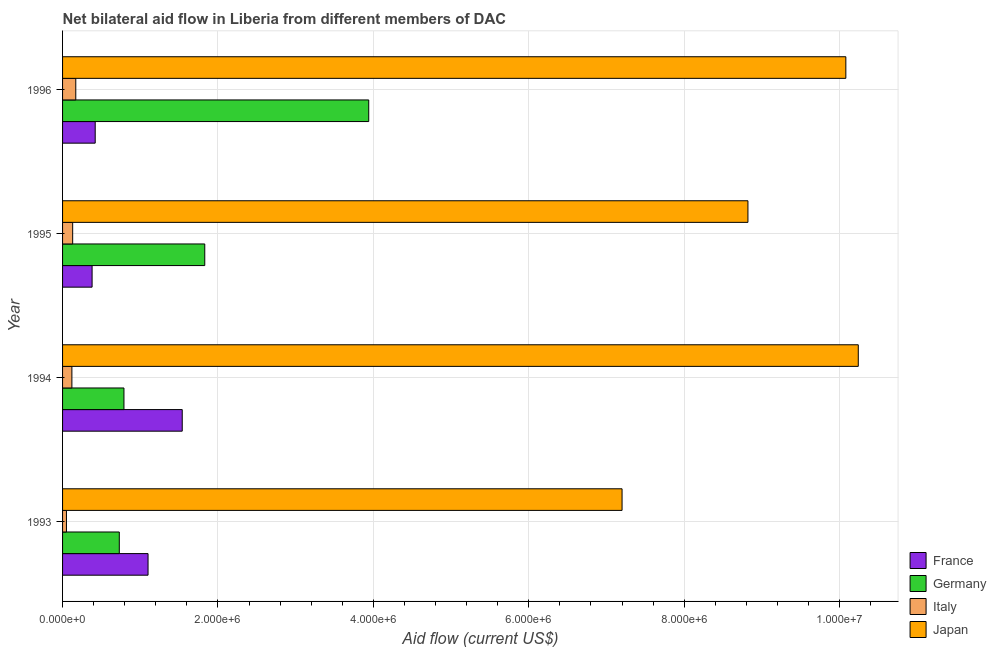How many different coloured bars are there?
Provide a succinct answer. 4. How many groups of bars are there?
Your answer should be very brief. 4. Are the number of bars per tick equal to the number of legend labels?
Offer a very short reply. Yes. Are the number of bars on each tick of the Y-axis equal?
Offer a terse response. Yes. How many bars are there on the 3rd tick from the top?
Your answer should be compact. 4. How many bars are there on the 1st tick from the bottom?
Ensure brevity in your answer.  4. In how many cases, is the number of bars for a given year not equal to the number of legend labels?
Offer a terse response. 0. What is the amount of aid given by france in 1993?
Make the answer very short. 1.10e+06. Across all years, what is the maximum amount of aid given by france?
Offer a terse response. 1.54e+06. Across all years, what is the minimum amount of aid given by germany?
Make the answer very short. 7.30e+05. In which year was the amount of aid given by italy maximum?
Make the answer very short. 1996. In which year was the amount of aid given by france minimum?
Your response must be concise. 1995. What is the total amount of aid given by france in the graph?
Your response must be concise. 3.44e+06. What is the difference between the amount of aid given by germany in 1993 and that in 1996?
Make the answer very short. -3.21e+06. What is the difference between the amount of aid given by italy in 1994 and the amount of aid given by germany in 1996?
Keep it short and to the point. -3.82e+06. What is the average amount of aid given by france per year?
Offer a very short reply. 8.60e+05. In the year 1996, what is the difference between the amount of aid given by germany and amount of aid given by italy?
Offer a very short reply. 3.77e+06. What is the ratio of the amount of aid given by italy in 1994 to that in 1995?
Your answer should be very brief. 0.92. Is the amount of aid given by germany in 1995 less than that in 1996?
Offer a very short reply. Yes. What is the difference between the highest and the lowest amount of aid given by germany?
Your answer should be very brief. 3.21e+06. In how many years, is the amount of aid given by japan greater than the average amount of aid given by japan taken over all years?
Keep it short and to the point. 2. How many bars are there?
Provide a succinct answer. 16. How many years are there in the graph?
Give a very brief answer. 4. What is the difference between two consecutive major ticks on the X-axis?
Your response must be concise. 2.00e+06. Are the values on the major ticks of X-axis written in scientific E-notation?
Keep it short and to the point. Yes. Does the graph contain any zero values?
Keep it short and to the point. No. Does the graph contain grids?
Ensure brevity in your answer.  Yes. Where does the legend appear in the graph?
Keep it short and to the point. Bottom right. How are the legend labels stacked?
Keep it short and to the point. Vertical. What is the title of the graph?
Your response must be concise. Net bilateral aid flow in Liberia from different members of DAC. Does "Budget management" appear as one of the legend labels in the graph?
Provide a succinct answer. No. What is the label or title of the X-axis?
Provide a succinct answer. Aid flow (current US$). What is the label or title of the Y-axis?
Make the answer very short. Year. What is the Aid flow (current US$) in France in 1993?
Offer a terse response. 1.10e+06. What is the Aid flow (current US$) in Germany in 1993?
Provide a succinct answer. 7.30e+05. What is the Aid flow (current US$) in Japan in 1993?
Offer a very short reply. 7.20e+06. What is the Aid flow (current US$) in France in 1994?
Keep it short and to the point. 1.54e+06. What is the Aid flow (current US$) in Germany in 1994?
Keep it short and to the point. 7.90e+05. What is the Aid flow (current US$) in Italy in 1994?
Offer a very short reply. 1.20e+05. What is the Aid flow (current US$) in Japan in 1994?
Offer a very short reply. 1.02e+07. What is the Aid flow (current US$) of Germany in 1995?
Ensure brevity in your answer.  1.83e+06. What is the Aid flow (current US$) of Italy in 1995?
Give a very brief answer. 1.30e+05. What is the Aid flow (current US$) in Japan in 1995?
Ensure brevity in your answer.  8.82e+06. What is the Aid flow (current US$) of Germany in 1996?
Offer a very short reply. 3.94e+06. What is the Aid flow (current US$) in Italy in 1996?
Provide a short and direct response. 1.70e+05. What is the Aid flow (current US$) of Japan in 1996?
Provide a short and direct response. 1.01e+07. Across all years, what is the maximum Aid flow (current US$) of France?
Give a very brief answer. 1.54e+06. Across all years, what is the maximum Aid flow (current US$) of Germany?
Your answer should be compact. 3.94e+06. Across all years, what is the maximum Aid flow (current US$) in Japan?
Your response must be concise. 1.02e+07. Across all years, what is the minimum Aid flow (current US$) in Germany?
Your answer should be compact. 7.30e+05. Across all years, what is the minimum Aid flow (current US$) in Italy?
Offer a very short reply. 5.00e+04. Across all years, what is the minimum Aid flow (current US$) of Japan?
Your response must be concise. 7.20e+06. What is the total Aid flow (current US$) of France in the graph?
Your answer should be very brief. 3.44e+06. What is the total Aid flow (current US$) in Germany in the graph?
Your answer should be very brief. 7.29e+06. What is the total Aid flow (current US$) in Italy in the graph?
Your answer should be very brief. 4.70e+05. What is the total Aid flow (current US$) in Japan in the graph?
Ensure brevity in your answer.  3.63e+07. What is the difference between the Aid flow (current US$) of France in 1993 and that in 1994?
Provide a succinct answer. -4.40e+05. What is the difference between the Aid flow (current US$) in Italy in 1993 and that in 1994?
Provide a short and direct response. -7.00e+04. What is the difference between the Aid flow (current US$) of Japan in 1993 and that in 1994?
Your answer should be compact. -3.04e+06. What is the difference between the Aid flow (current US$) of France in 1993 and that in 1995?
Ensure brevity in your answer.  7.20e+05. What is the difference between the Aid flow (current US$) in Germany in 1993 and that in 1995?
Your answer should be very brief. -1.10e+06. What is the difference between the Aid flow (current US$) of Italy in 1993 and that in 1995?
Ensure brevity in your answer.  -8.00e+04. What is the difference between the Aid flow (current US$) of Japan in 1993 and that in 1995?
Your answer should be very brief. -1.62e+06. What is the difference between the Aid flow (current US$) of France in 1993 and that in 1996?
Your response must be concise. 6.80e+05. What is the difference between the Aid flow (current US$) in Germany in 1993 and that in 1996?
Offer a very short reply. -3.21e+06. What is the difference between the Aid flow (current US$) in Italy in 1993 and that in 1996?
Keep it short and to the point. -1.20e+05. What is the difference between the Aid flow (current US$) in Japan in 1993 and that in 1996?
Offer a terse response. -2.88e+06. What is the difference between the Aid flow (current US$) in France in 1994 and that in 1995?
Your answer should be compact. 1.16e+06. What is the difference between the Aid flow (current US$) of Germany in 1994 and that in 1995?
Provide a short and direct response. -1.04e+06. What is the difference between the Aid flow (current US$) in Japan in 1994 and that in 1995?
Offer a very short reply. 1.42e+06. What is the difference between the Aid flow (current US$) in France in 1994 and that in 1996?
Your response must be concise. 1.12e+06. What is the difference between the Aid flow (current US$) of Germany in 1994 and that in 1996?
Offer a terse response. -3.15e+06. What is the difference between the Aid flow (current US$) of Germany in 1995 and that in 1996?
Your answer should be very brief. -2.11e+06. What is the difference between the Aid flow (current US$) in Italy in 1995 and that in 1996?
Offer a terse response. -4.00e+04. What is the difference between the Aid flow (current US$) of Japan in 1995 and that in 1996?
Give a very brief answer. -1.26e+06. What is the difference between the Aid flow (current US$) in France in 1993 and the Aid flow (current US$) in Italy in 1994?
Your answer should be very brief. 9.80e+05. What is the difference between the Aid flow (current US$) in France in 1993 and the Aid flow (current US$) in Japan in 1994?
Keep it short and to the point. -9.14e+06. What is the difference between the Aid flow (current US$) of Germany in 1993 and the Aid flow (current US$) of Japan in 1994?
Your answer should be very brief. -9.51e+06. What is the difference between the Aid flow (current US$) in Italy in 1993 and the Aid flow (current US$) in Japan in 1994?
Your answer should be very brief. -1.02e+07. What is the difference between the Aid flow (current US$) of France in 1993 and the Aid flow (current US$) of Germany in 1995?
Give a very brief answer. -7.30e+05. What is the difference between the Aid flow (current US$) in France in 1993 and the Aid flow (current US$) in Italy in 1995?
Ensure brevity in your answer.  9.70e+05. What is the difference between the Aid flow (current US$) of France in 1993 and the Aid flow (current US$) of Japan in 1995?
Provide a succinct answer. -7.72e+06. What is the difference between the Aid flow (current US$) of Germany in 1993 and the Aid flow (current US$) of Japan in 1995?
Keep it short and to the point. -8.09e+06. What is the difference between the Aid flow (current US$) in Italy in 1993 and the Aid flow (current US$) in Japan in 1995?
Make the answer very short. -8.77e+06. What is the difference between the Aid flow (current US$) of France in 1993 and the Aid flow (current US$) of Germany in 1996?
Keep it short and to the point. -2.84e+06. What is the difference between the Aid flow (current US$) in France in 1993 and the Aid flow (current US$) in Italy in 1996?
Keep it short and to the point. 9.30e+05. What is the difference between the Aid flow (current US$) in France in 1993 and the Aid flow (current US$) in Japan in 1996?
Keep it short and to the point. -8.98e+06. What is the difference between the Aid flow (current US$) in Germany in 1993 and the Aid flow (current US$) in Italy in 1996?
Make the answer very short. 5.60e+05. What is the difference between the Aid flow (current US$) of Germany in 1993 and the Aid flow (current US$) of Japan in 1996?
Offer a terse response. -9.35e+06. What is the difference between the Aid flow (current US$) of Italy in 1993 and the Aid flow (current US$) of Japan in 1996?
Keep it short and to the point. -1.00e+07. What is the difference between the Aid flow (current US$) of France in 1994 and the Aid flow (current US$) of Italy in 1995?
Keep it short and to the point. 1.41e+06. What is the difference between the Aid flow (current US$) in France in 1994 and the Aid flow (current US$) in Japan in 1995?
Keep it short and to the point. -7.28e+06. What is the difference between the Aid flow (current US$) of Germany in 1994 and the Aid flow (current US$) of Italy in 1995?
Give a very brief answer. 6.60e+05. What is the difference between the Aid flow (current US$) in Germany in 1994 and the Aid flow (current US$) in Japan in 1995?
Keep it short and to the point. -8.03e+06. What is the difference between the Aid flow (current US$) of Italy in 1994 and the Aid flow (current US$) of Japan in 1995?
Give a very brief answer. -8.70e+06. What is the difference between the Aid flow (current US$) of France in 1994 and the Aid flow (current US$) of Germany in 1996?
Offer a terse response. -2.40e+06. What is the difference between the Aid flow (current US$) in France in 1994 and the Aid flow (current US$) in Italy in 1996?
Ensure brevity in your answer.  1.37e+06. What is the difference between the Aid flow (current US$) in France in 1994 and the Aid flow (current US$) in Japan in 1996?
Your response must be concise. -8.54e+06. What is the difference between the Aid flow (current US$) in Germany in 1994 and the Aid flow (current US$) in Italy in 1996?
Keep it short and to the point. 6.20e+05. What is the difference between the Aid flow (current US$) in Germany in 1994 and the Aid flow (current US$) in Japan in 1996?
Offer a terse response. -9.29e+06. What is the difference between the Aid flow (current US$) of Italy in 1994 and the Aid flow (current US$) of Japan in 1996?
Give a very brief answer. -9.96e+06. What is the difference between the Aid flow (current US$) in France in 1995 and the Aid flow (current US$) in Germany in 1996?
Your answer should be very brief. -3.56e+06. What is the difference between the Aid flow (current US$) in France in 1995 and the Aid flow (current US$) in Italy in 1996?
Provide a succinct answer. 2.10e+05. What is the difference between the Aid flow (current US$) in France in 1995 and the Aid flow (current US$) in Japan in 1996?
Provide a succinct answer. -9.70e+06. What is the difference between the Aid flow (current US$) of Germany in 1995 and the Aid flow (current US$) of Italy in 1996?
Give a very brief answer. 1.66e+06. What is the difference between the Aid flow (current US$) in Germany in 1995 and the Aid flow (current US$) in Japan in 1996?
Give a very brief answer. -8.25e+06. What is the difference between the Aid flow (current US$) in Italy in 1995 and the Aid flow (current US$) in Japan in 1996?
Ensure brevity in your answer.  -9.95e+06. What is the average Aid flow (current US$) in France per year?
Keep it short and to the point. 8.60e+05. What is the average Aid flow (current US$) in Germany per year?
Your answer should be very brief. 1.82e+06. What is the average Aid flow (current US$) in Italy per year?
Your answer should be very brief. 1.18e+05. What is the average Aid flow (current US$) of Japan per year?
Offer a very short reply. 9.08e+06. In the year 1993, what is the difference between the Aid flow (current US$) in France and Aid flow (current US$) in Italy?
Provide a short and direct response. 1.05e+06. In the year 1993, what is the difference between the Aid flow (current US$) in France and Aid flow (current US$) in Japan?
Provide a short and direct response. -6.10e+06. In the year 1993, what is the difference between the Aid flow (current US$) of Germany and Aid flow (current US$) of Italy?
Provide a short and direct response. 6.80e+05. In the year 1993, what is the difference between the Aid flow (current US$) of Germany and Aid flow (current US$) of Japan?
Provide a short and direct response. -6.47e+06. In the year 1993, what is the difference between the Aid flow (current US$) of Italy and Aid flow (current US$) of Japan?
Offer a very short reply. -7.15e+06. In the year 1994, what is the difference between the Aid flow (current US$) of France and Aid flow (current US$) of Germany?
Your answer should be very brief. 7.50e+05. In the year 1994, what is the difference between the Aid flow (current US$) in France and Aid flow (current US$) in Italy?
Your response must be concise. 1.42e+06. In the year 1994, what is the difference between the Aid flow (current US$) in France and Aid flow (current US$) in Japan?
Your answer should be compact. -8.70e+06. In the year 1994, what is the difference between the Aid flow (current US$) in Germany and Aid flow (current US$) in Italy?
Offer a very short reply. 6.70e+05. In the year 1994, what is the difference between the Aid flow (current US$) of Germany and Aid flow (current US$) of Japan?
Make the answer very short. -9.45e+06. In the year 1994, what is the difference between the Aid flow (current US$) in Italy and Aid flow (current US$) in Japan?
Give a very brief answer. -1.01e+07. In the year 1995, what is the difference between the Aid flow (current US$) of France and Aid flow (current US$) of Germany?
Keep it short and to the point. -1.45e+06. In the year 1995, what is the difference between the Aid flow (current US$) of France and Aid flow (current US$) of Japan?
Provide a succinct answer. -8.44e+06. In the year 1995, what is the difference between the Aid flow (current US$) in Germany and Aid flow (current US$) in Italy?
Offer a very short reply. 1.70e+06. In the year 1995, what is the difference between the Aid flow (current US$) in Germany and Aid flow (current US$) in Japan?
Offer a very short reply. -6.99e+06. In the year 1995, what is the difference between the Aid flow (current US$) of Italy and Aid flow (current US$) of Japan?
Your response must be concise. -8.69e+06. In the year 1996, what is the difference between the Aid flow (current US$) of France and Aid flow (current US$) of Germany?
Make the answer very short. -3.52e+06. In the year 1996, what is the difference between the Aid flow (current US$) in France and Aid flow (current US$) in Italy?
Give a very brief answer. 2.50e+05. In the year 1996, what is the difference between the Aid flow (current US$) of France and Aid flow (current US$) of Japan?
Make the answer very short. -9.66e+06. In the year 1996, what is the difference between the Aid flow (current US$) of Germany and Aid flow (current US$) of Italy?
Make the answer very short. 3.77e+06. In the year 1996, what is the difference between the Aid flow (current US$) of Germany and Aid flow (current US$) of Japan?
Offer a terse response. -6.14e+06. In the year 1996, what is the difference between the Aid flow (current US$) in Italy and Aid flow (current US$) in Japan?
Your answer should be compact. -9.91e+06. What is the ratio of the Aid flow (current US$) in Germany in 1993 to that in 1994?
Your response must be concise. 0.92. What is the ratio of the Aid flow (current US$) of Italy in 1993 to that in 1994?
Your response must be concise. 0.42. What is the ratio of the Aid flow (current US$) in Japan in 1993 to that in 1994?
Your response must be concise. 0.7. What is the ratio of the Aid flow (current US$) of France in 1993 to that in 1995?
Keep it short and to the point. 2.89. What is the ratio of the Aid flow (current US$) of Germany in 1993 to that in 1995?
Offer a terse response. 0.4. What is the ratio of the Aid flow (current US$) of Italy in 1993 to that in 1995?
Your response must be concise. 0.38. What is the ratio of the Aid flow (current US$) in Japan in 1993 to that in 1995?
Make the answer very short. 0.82. What is the ratio of the Aid flow (current US$) of France in 1993 to that in 1996?
Your answer should be very brief. 2.62. What is the ratio of the Aid flow (current US$) of Germany in 1993 to that in 1996?
Provide a short and direct response. 0.19. What is the ratio of the Aid flow (current US$) in Italy in 1993 to that in 1996?
Your answer should be compact. 0.29. What is the ratio of the Aid flow (current US$) of France in 1994 to that in 1995?
Provide a succinct answer. 4.05. What is the ratio of the Aid flow (current US$) of Germany in 1994 to that in 1995?
Keep it short and to the point. 0.43. What is the ratio of the Aid flow (current US$) in Italy in 1994 to that in 1995?
Make the answer very short. 0.92. What is the ratio of the Aid flow (current US$) of Japan in 1994 to that in 1995?
Make the answer very short. 1.16. What is the ratio of the Aid flow (current US$) in France in 1994 to that in 1996?
Your answer should be very brief. 3.67. What is the ratio of the Aid flow (current US$) in Germany in 1994 to that in 1996?
Provide a short and direct response. 0.2. What is the ratio of the Aid flow (current US$) of Italy in 1994 to that in 1996?
Offer a terse response. 0.71. What is the ratio of the Aid flow (current US$) of Japan in 1994 to that in 1996?
Make the answer very short. 1.02. What is the ratio of the Aid flow (current US$) in France in 1995 to that in 1996?
Make the answer very short. 0.9. What is the ratio of the Aid flow (current US$) in Germany in 1995 to that in 1996?
Your answer should be compact. 0.46. What is the ratio of the Aid flow (current US$) in Italy in 1995 to that in 1996?
Give a very brief answer. 0.76. What is the difference between the highest and the second highest Aid flow (current US$) of France?
Your answer should be compact. 4.40e+05. What is the difference between the highest and the second highest Aid flow (current US$) of Germany?
Keep it short and to the point. 2.11e+06. What is the difference between the highest and the second highest Aid flow (current US$) in Italy?
Offer a terse response. 4.00e+04. What is the difference between the highest and the lowest Aid flow (current US$) in France?
Give a very brief answer. 1.16e+06. What is the difference between the highest and the lowest Aid flow (current US$) of Germany?
Your answer should be compact. 3.21e+06. What is the difference between the highest and the lowest Aid flow (current US$) of Japan?
Keep it short and to the point. 3.04e+06. 